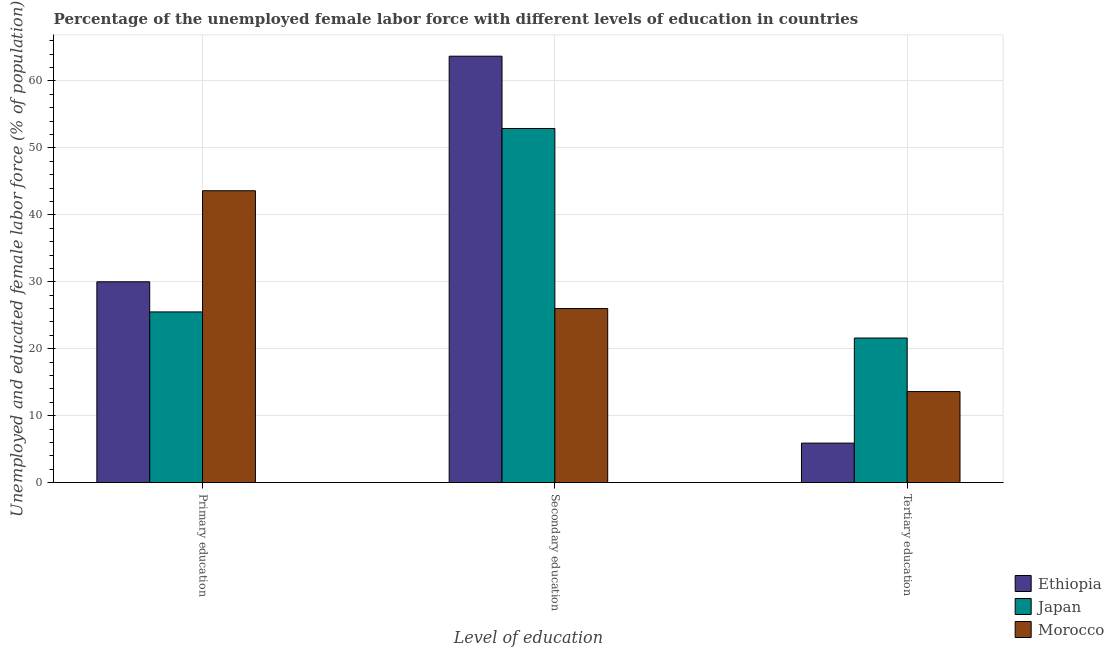How many groups of bars are there?
Offer a terse response. 3. Are the number of bars per tick equal to the number of legend labels?
Your answer should be very brief. Yes. How many bars are there on the 1st tick from the left?
Your answer should be compact. 3. How many bars are there on the 2nd tick from the right?
Offer a very short reply. 3. What is the label of the 2nd group of bars from the left?
Offer a very short reply. Secondary education. What is the percentage of female labor force who received tertiary education in Ethiopia?
Offer a very short reply. 5.9. Across all countries, what is the maximum percentage of female labor force who received tertiary education?
Keep it short and to the point. 21.6. Across all countries, what is the minimum percentage of female labor force who received primary education?
Your response must be concise. 25.5. In which country was the percentage of female labor force who received primary education maximum?
Provide a short and direct response. Morocco. In which country was the percentage of female labor force who received secondary education minimum?
Keep it short and to the point. Morocco. What is the total percentage of female labor force who received secondary education in the graph?
Offer a terse response. 142.6. What is the difference between the percentage of female labor force who received primary education in Ethiopia and that in Morocco?
Provide a succinct answer. -13.6. What is the difference between the percentage of female labor force who received primary education in Japan and the percentage of female labor force who received tertiary education in Morocco?
Provide a succinct answer. 11.9. What is the average percentage of female labor force who received tertiary education per country?
Your answer should be very brief. 13.7. What is the difference between the percentage of female labor force who received primary education and percentage of female labor force who received tertiary education in Japan?
Your response must be concise. 3.9. In how many countries, is the percentage of female labor force who received secondary education greater than 2 %?
Keep it short and to the point. 3. What is the ratio of the percentage of female labor force who received secondary education in Ethiopia to that in Japan?
Offer a terse response. 1.2. What is the difference between the highest and the second highest percentage of female labor force who received primary education?
Provide a short and direct response. 13.6. What is the difference between the highest and the lowest percentage of female labor force who received primary education?
Your response must be concise. 18.1. In how many countries, is the percentage of female labor force who received secondary education greater than the average percentage of female labor force who received secondary education taken over all countries?
Your response must be concise. 2. What does the 1st bar from the right in Secondary education represents?
Make the answer very short. Morocco. Is it the case that in every country, the sum of the percentage of female labor force who received primary education and percentage of female labor force who received secondary education is greater than the percentage of female labor force who received tertiary education?
Keep it short and to the point. Yes. Are the values on the major ticks of Y-axis written in scientific E-notation?
Ensure brevity in your answer.  No. Does the graph contain any zero values?
Give a very brief answer. No. Does the graph contain grids?
Offer a terse response. Yes. Where does the legend appear in the graph?
Provide a succinct answer. Bottom right. How many legend labels are there?
Your response must be concise. 3. What is the title of the graph?
Ensure brevity in your answer.  Percentage of the unemployed female labor force with different levels of education in countries. Does "Portugal" appear as one of the legend labels in the graph?
Offer a very short reply. No. What is the label or title of the X-axis?
Provide a short and direct response. Level of education. What is the label or title of the Y-axis?
Your response must be concise. Unemployed and educated female labor force (% of population). What is the Unemployed and educated female labor force (% of population) in Japan in Primary education?
Your response must be concise. 25.5. What is the Unemployed and educated female labor force (% of population) of Morocco in Primary education?
Your answer should be very brief. 43.6. What is the Unemployed and educated female labor force (% of population) in Ethiopia in Secondary education?
Your answer should be very brief. 63.7. What is the Unemployed and educated female labor force (% of population) in Japan in Secondary education?
Your answer should be very brief. 52.9. What is the Unemployed and educated female labor force (% of population) of Ethiopia in Tertiary education?
Keep it short and to the point. 5.9. What is the Unemployed and educated female labor force (% of population) of Japan in Tertiary education?
Your response must be concise. 21.6. What is the Unemployed and educated female labor force (% of population) of Morocco in Tertiary education?
Ensure brevity in your answer.  13.6. Across all Level of education, what is the maximum Unemployed and educated female labor force (% of population) of Ethiopia?
Offer a very short reply. 63.7. Across all Level of education, what is the maximum Unemployed and educated female labor force (% of population) of Japan?
Give a very brief answer. 52.9. Across all Level of education, what is the maximum Unemployed and educated female labor force (% of population) in Morocco?
Offer a terse response. 43.6. Across all Level of education, what is the minimum Unemployed and educated female labor force (% of population) of Ethiopia?
Make the answer very short. 5.9. Across all Level of education, what is the minimum Unemployed and educated female labor force (% of population) in Japan?
Ensure brevity in your answer.  21.6. Across all Level of education, what is the minimum Unemployed and educated female labor force (% of population) in Morocco?
Keep it short and to the point. 13.6. What is the total Unemployed and educated female labor force (% of population) of Ethiopia in the graph?
Your response must be concise. 99.6. What is the total Unemployed and educated female labor force (% of population) in Morocco in the graph?
Your answer should be very brief. 83.2. What is the difference between the Unemployed and educated female labor force (% of population) in Ethiopia in Primary education and that in Secondary education?
Make the answer very short. -33.7. What is the difference between the Unemployed and educated female labor force (% of population) of Japan in Primary education and that in Secondary education?
Provide a succinct answer. -27.4. What is the difference between the Unemployed and educated female labor force (% of population) of Ethiopia in Primary education and that in Tertiary education?
Provide a short and direct response. 24.1. What is the difference between the Unemployed and educated female labor force (% of population) in Japan in Primary education and that in Tertiary education?
Give a very brief answer. 3.9. What is the difference between the Unemployed and educated female labor force (% of population) in Morocco in Primary education and that in Tertiary education?
Offer a terse response. 30. What is the difference between the Unemployed and educated female labor force (% of population) of Ethiopia in Secondary education and that in Tertiary education?
Give a very brief answer. 57.8. What is the difference between the Unemployed and educated female labor force (% of population) in Japan in Secondary education and that in Tertiary education?
Make the answer very short. 31.3. What is the difference between the Unemployed and educated female labor force (% of population) in Ethiopia in Primary education and the Unemployed and educated female labor force (% of population) in Japan in Secondary education?
Your answer should be compact. -22.9. What is the difference between the Unemployed and educated female labor force (% of population) in Ethiopia in Primary education and the Unemployed and educated female labor force (% of population) in Morocco in Secondary education?
Provide a succinct answer. 4. What is the difference between the Unemployed and educated female labor force (% of population) of Ethiopia in Primary education and the Unemployed and educated female labor force (% of population) of Japan in Tertiary education?
Your response must be concise. 8.4. What is the difference between the Unemployed and educated female labor force (% of population) of Ethiopia in Secondary education and the Unemployed and educated female labor force (% of population) of Japan in Tertiary education?
Offer a terse response. 42.1. What is the difference between the Unemployed and educated female labor force (% of population) of Ethiopia in Secondary education and the Unemployed and educated female labor force (% of population) of Morocco in Tertiary education?
Keep it short and to the point. 50.1. What is the difference between the Unemployed and educated female labor force (% of population) in Japan in Secondary education and the Unemployed and educated female labor force (% of population) in Morocco in Tertiary education?
Your answer should be very brief. 39.3. What is the average Unemployed and educated female labor force (% of population) in Ethiopia per Level of education?
Ensure brevity in your answer.  33.2. What is the average Unemployed and educated female labor force (% of population) in Japan per Level of education?
Your answer should be very brief. 33.33. What is the average Unemployed and educated female labor force (% of population) of Morocco per Level of education?
Keep it short and to the point. 27.73. What is the difference between the Unemployed and educated female labor force (% of population) in Japan and Unemployed and educated female labor force (% of population) in Morocco in Primary education?
Give a very brief answer. -18.1. What is the difference between the Unemployed and educated female labor force (% of population) of Ethiopia and Unemployed and educated female labor force (% of population) of Morocco in Secondary education?
Give a very brief answer. 37.7. What is the difference between the Unemployed and educated female labor force (% of population) of Japan and Unemployed and educated female labor force (% of population) of Morocco in Secondary education?
Ensure brevity in your answer.  26.9. What is the difference between the Unemployed and educated female labor force (% of population) in Ethiopia and Unemployed and educated female labor force (% of population) in Japan in Tertiary education?
Ensure brevity in your answer.  -15.7. What is the difference between the Unemployed and educated female labor force (% of population) of Japan and Unemployed and educated female labor force (% of population) of Morocco in Tertiary education?
Make the answer very short. 8. What is the ratio of the Unemployed and educated female labor force (% of population) in Ethiopia in Primary education to that in Secondary education?
Keep it short and to the point. 0.47. What is the ratio of the Unemployed and educated female labor force (% of population) in Japan in Primary education to that in Secondary education?
Keep it short and to the point. 0.48. What is the ratio of the Unemployed and educated female labor force (% of population) of Morocco in Primary education to that in Secondary education?
Keep it short and to the point. 1.68. What is the ratio of the Unemployed and educated female labor force (% of population) of Ethiopia in Primary education to that in Tertiary education?
Ensure brevity in your answer.  5.08. What is the ratio of the Unemployed and educated female labor force (% of population) in Japan in Primary education to that in Tertiary education?
Offer a very short reply. 1.18. What is the ratio of the Unemployed and educated female labor force (% of population) in Morocco in Primary education to that in Tertiary education?
Ensure brevity in your answer.  3.21. What is the ratio of the Unemployed and educated female labor force (% of population) of Ethiopia in Secondary education to that in Tertiary education?
Provide a succinct answer. 10.8. What is the ratio of the Unemployed and educated female labor force (% of population) in Japan in Secondary education to that in Tertiary education?
Provide a short and direct response. 2.45. What is the ratio of the Unemployed and educated female labor force (% of population) of Morocco in Secondary education to that in Tertiary education?
Your answer should be compact. 1.91. What is the difference between the highest and the second highest Unemployed and educated female labor force (% of population) in Ethiopia?
Offer a very short reply. 33.7. What is the difference between the highest and the second highest Unemployed and educated female labor force (% of population) in Japan?
Your answer should be compact. 27.4. What is the difference between the highest and the second highest Unemployed and educated female labor force (% of population) of Morocco?
Provide a succinct answer. 17.6. What is the difference between the highest and the lowest Unemployed and educated female labor force (% of population) in Ethiopia?
Your response must be concise. 57.8. What is the difference between the highest and the lowest Unemployed and educated female labor force (% of population) of Japan?
Your answer should be very brief. 31.3. 